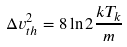<formula> <loc_0><loc_0><loc_500><loc_500>\Delta v _ { t h } ^ { 2 } = 8 \ln 2 \frac { k T _ { k } } { m }</formula> 